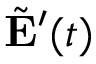Convert formula to latex. <formula><loc_0><loc_0><loc_500><loc_500>\tilde { E } ^ { \prime } ( t )</formula> 